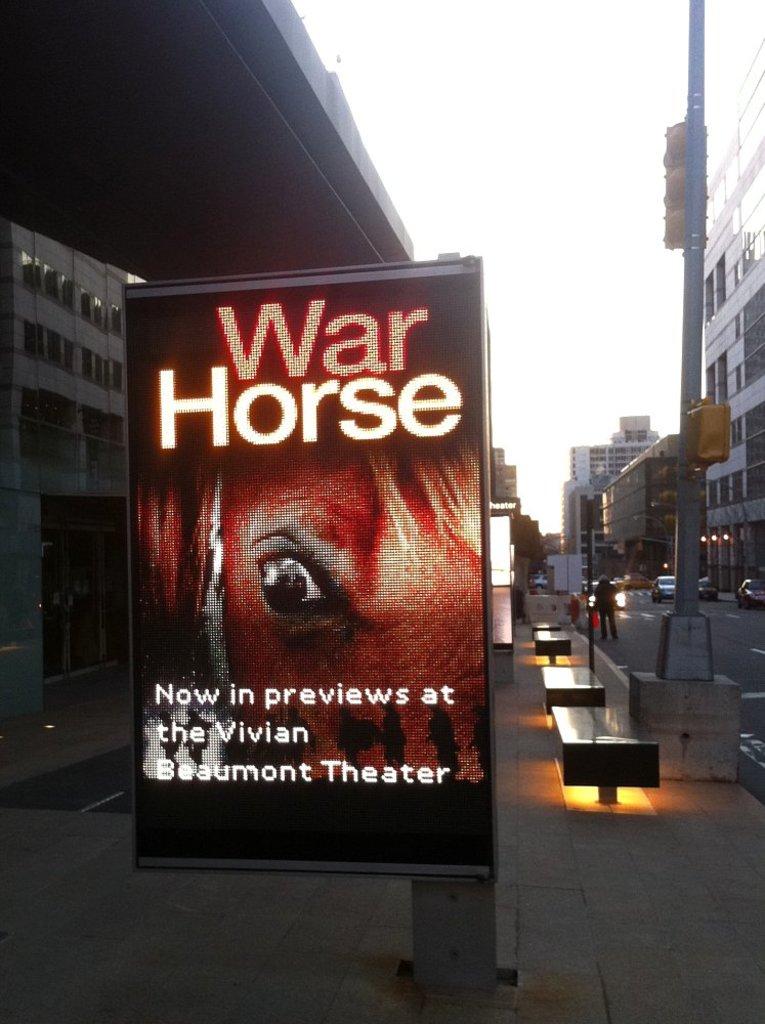What's the name of this movie?
Your answer should be compact. War horse. Is this movie in previews?
Give a very brief answer. Yes. 